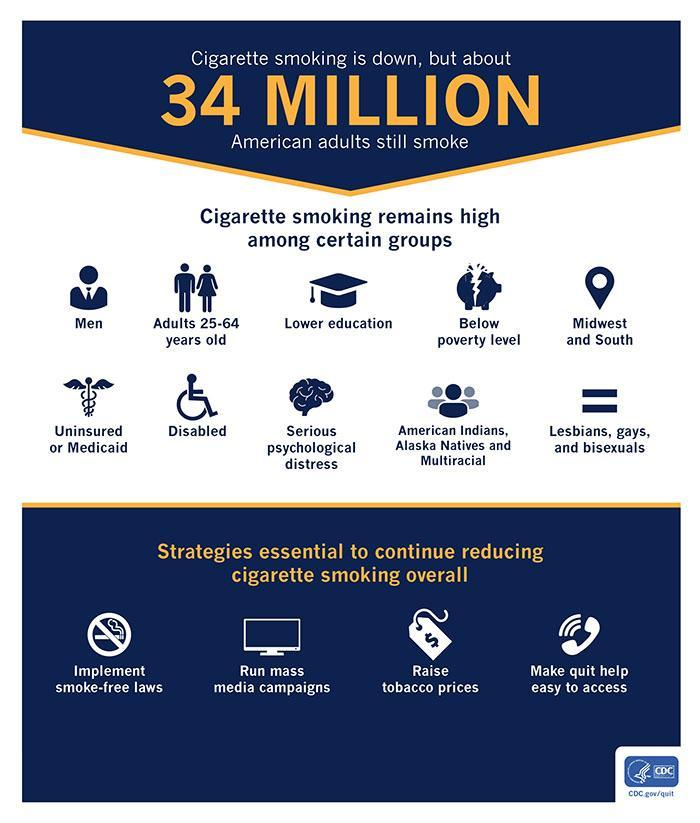In which region of America, cigarette smoking remains high?
Answer the question with a short phrase. Midwest and South What strategy is essential to reduce the overall cigarette smoking in context of laws? Implement smoke-free laws What is the american population that is involved in smoking of cigarettes? 34 MILLION What strategy is essential to reduce the overall cigarette smoking incase of media? Run mass media campaigns In which age group of adults, cigarette smoking remains high in America? Adults 25-64 years old 